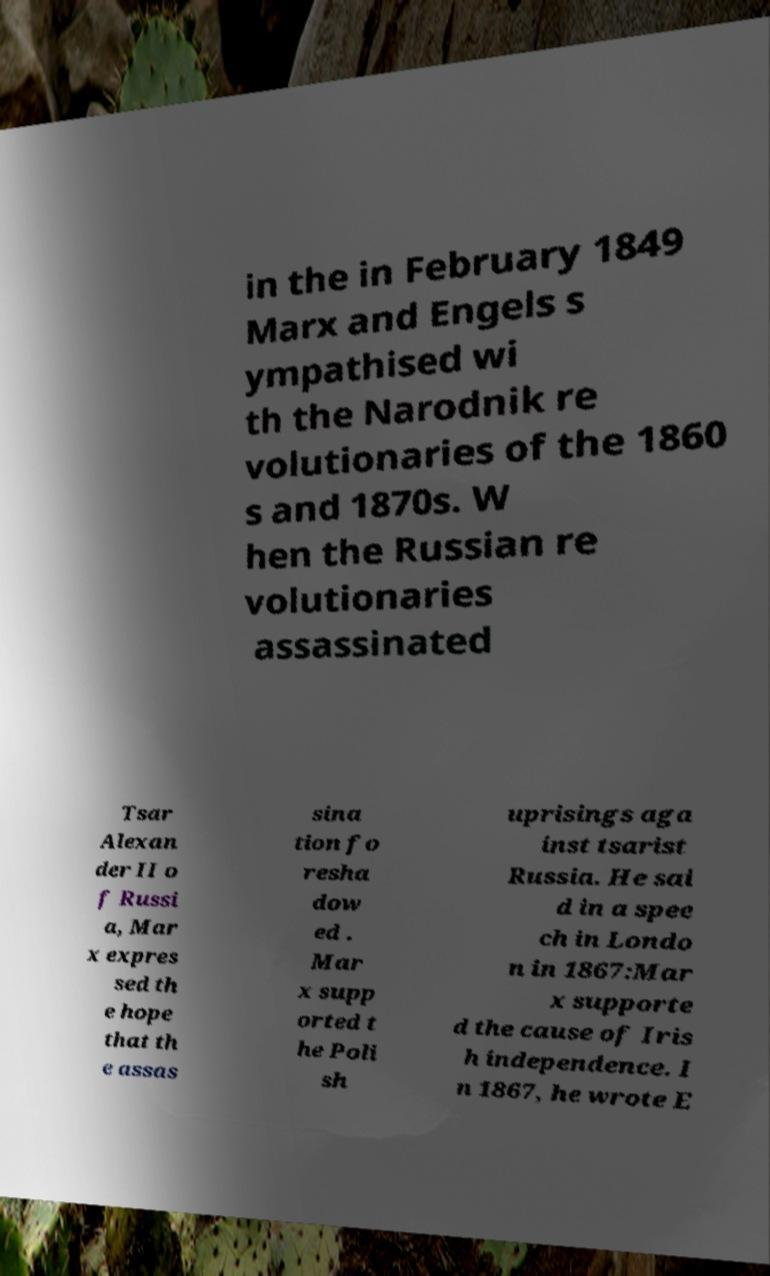Could you extract and type out the text from this image? in the in February 1849 Marx and Engels s ympathised wi th the Narodnik re volutionaries of the 1860 s and 1870s. W hen the Russian re volutionaries assassinated Tsar Alexan der II o f Russi a, Mar x expres sed th e hope that th e assas sina tion fo resha dow ed . Mar x supp orted t he Poli sh uprisings aga inst tsarist Russia. He sai d in a spee ch in Londo n in 1867:Mar x supporte d the cause of Iris h independence. I n 1867, he wrote E 